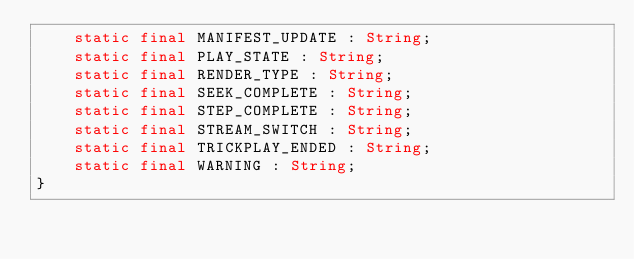<code> <loc_0><loc_0><loc_500><loc_500><_Haxe_>	static final MANIFEST_UPDATE : String;
	static final PLAY_STATE : String;
	static final RENDER_TYPE : String;
	static final SEEK_COMPLETE : String;
	static final STEP_COMPLETE : String;
	static final STREAM_SWITCH : String;
	static final TRICKPLAY_ENDED : String;
	static final WARNING : String;
}
</code> 